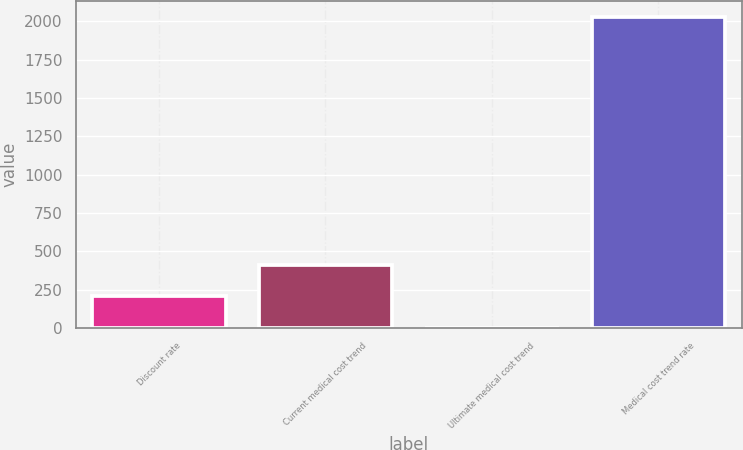<chart> <loc_0><loc_0><loc_500><loc_500><bar_chart><fcel>Discount rate<fcel>Current medical cost trend<fcel>Ultimate medical cost trend<fcel>Medical cost trend rate<nl><fcel>206.05<fcel>408.6<fcel>3.5<fcel>2029<nl></chart> 